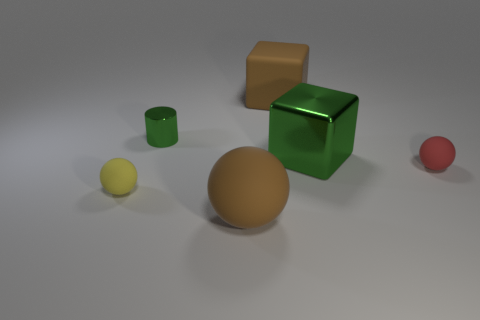Are the brown thing that is to the right of the brown sphere and the tiny sphere on the right side of the large ball made of the same material?
Your answer should be compact. Yes. There is a large brown matte thing that is in front of the big brown matte object behind the metal cylinder; what number of tiny balls are behind it?
Offer a very short reply. 2. There is a rubber thing that is right of the green block; is its color the same as the tiny object that is behind the big green object?
Keep it short and to the point. No. Are there any other things that have the same color as the big matte ball?
Ensure brevity in your answer.  Yes. There is a tiny matte sphere right of the ball that is to the left of the green cylinder; what is its color?
Provide a short and direct response. Red. Are any large green cubes visible?
Keep it short and to the point. Yes. There is a matte ball that is both in front of the red matte object and on the right side of the small cylinder; what color is it?
Your answer should be very brief. Brown. Is the size of the thing that is behind the metal cylinder the same as the object that is on the left side of the small green cylinder?
Provide a short and direct response. No. What number of other things are the same size as the green metal block?
Ensure brevity in your answer.  2. How many big brown rubber things are in front of the sphere that is right of the brown matte cube?
Offer a very short reply. 1. 